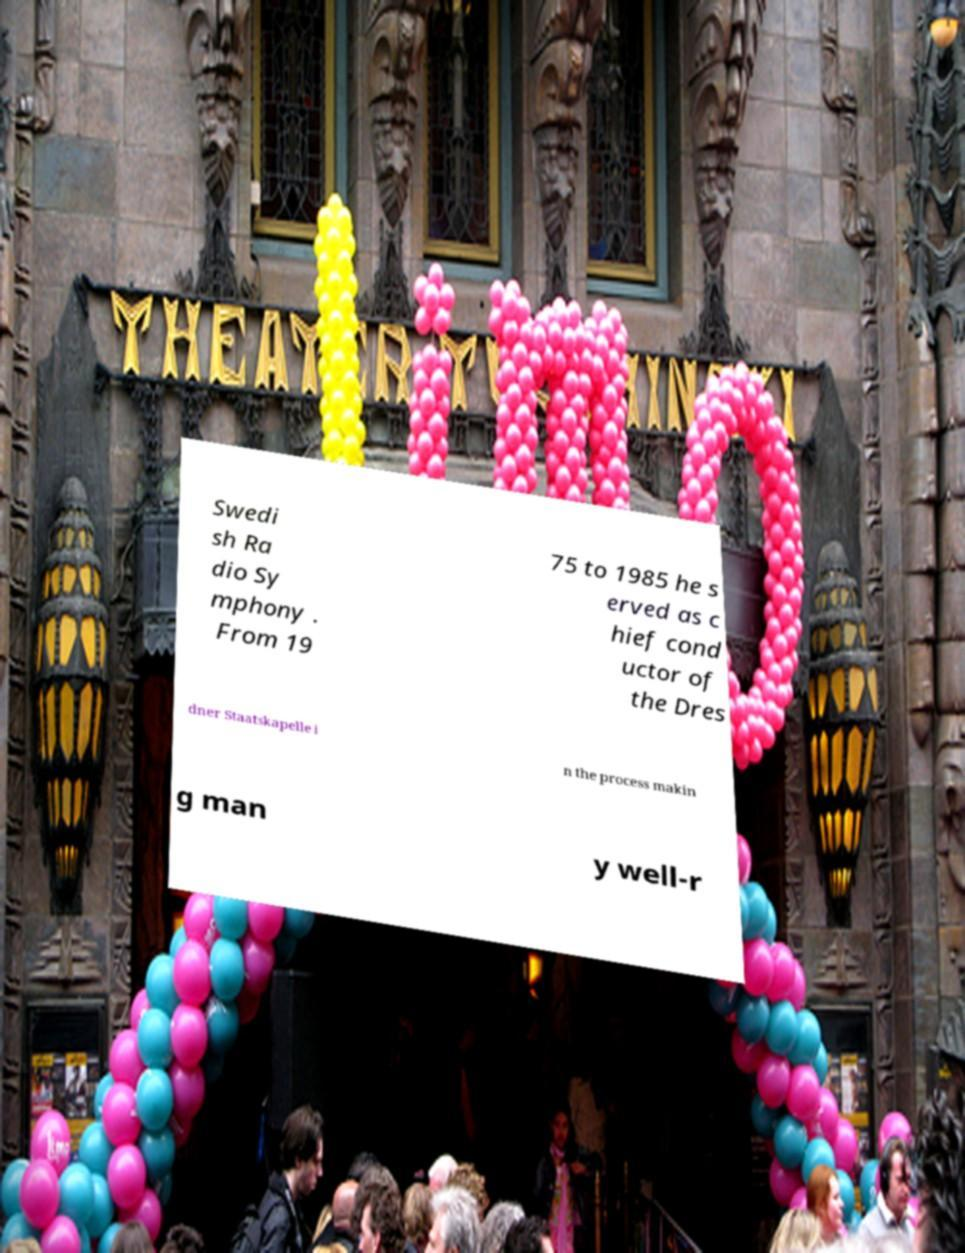I need the written content from this picture converted into text. Can you do that? Swedi sh Ra dio Sy mphony . From 19 75 to 1985 he s erved as c hief cond uctor of the Dres dner Staatskapelle i n the process makin g man y well-r 